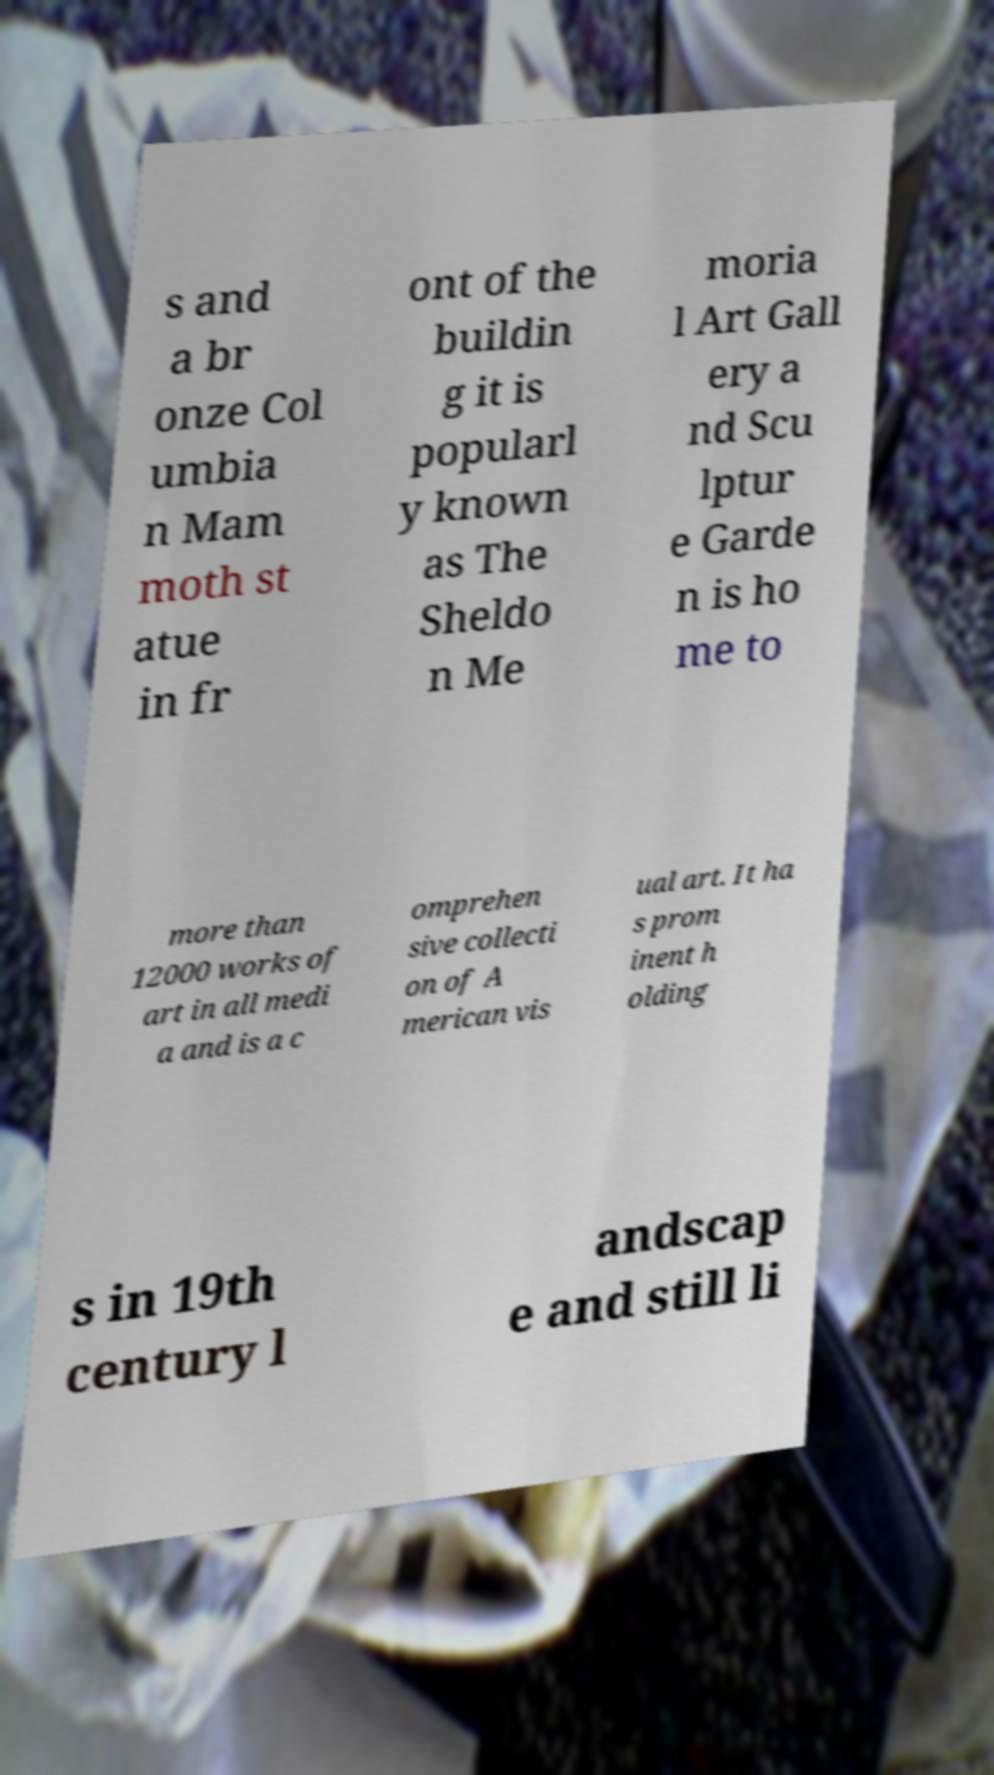I need the written content from this picture converted into text. Can you do that? s and a br onze Col umbia n Mam moth st atue in fr ont of the buildin g it is popularl y known as The Sheldo n Me moria l Art Gall ery a nd Scu lptur e Garde n is ho me to more than 12000 works of art in all medi a and is a c omprehen sive collecti on of A merican vis ual art. It ha s prom inent h olding s in 19th century l andscap e and still li 